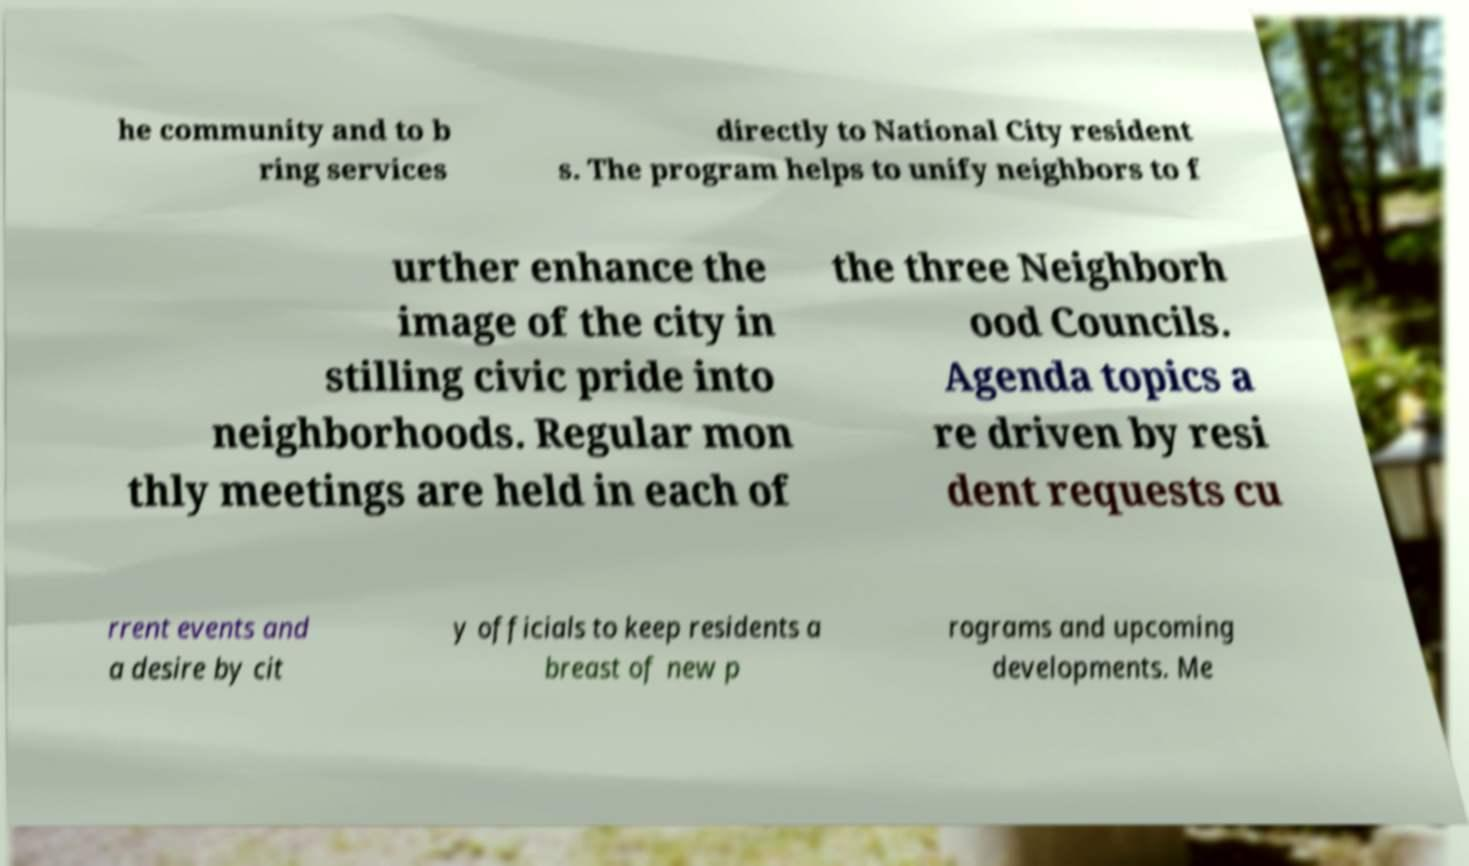Could you extract and type out the text from this image? he community and to b ring services directly to National City resident s. The program helps to unify neighbors to f urther enhance the image of the city in stilling civic pride into neighborhoods. Regular mon thly meetings are held in each of the three Neighborh ood Councils. Agenda topics a re driven by resi dent requests cu rrent events and a desire by cit y officials to keep residents a breast of new p rograms and upcoming developments. Me 